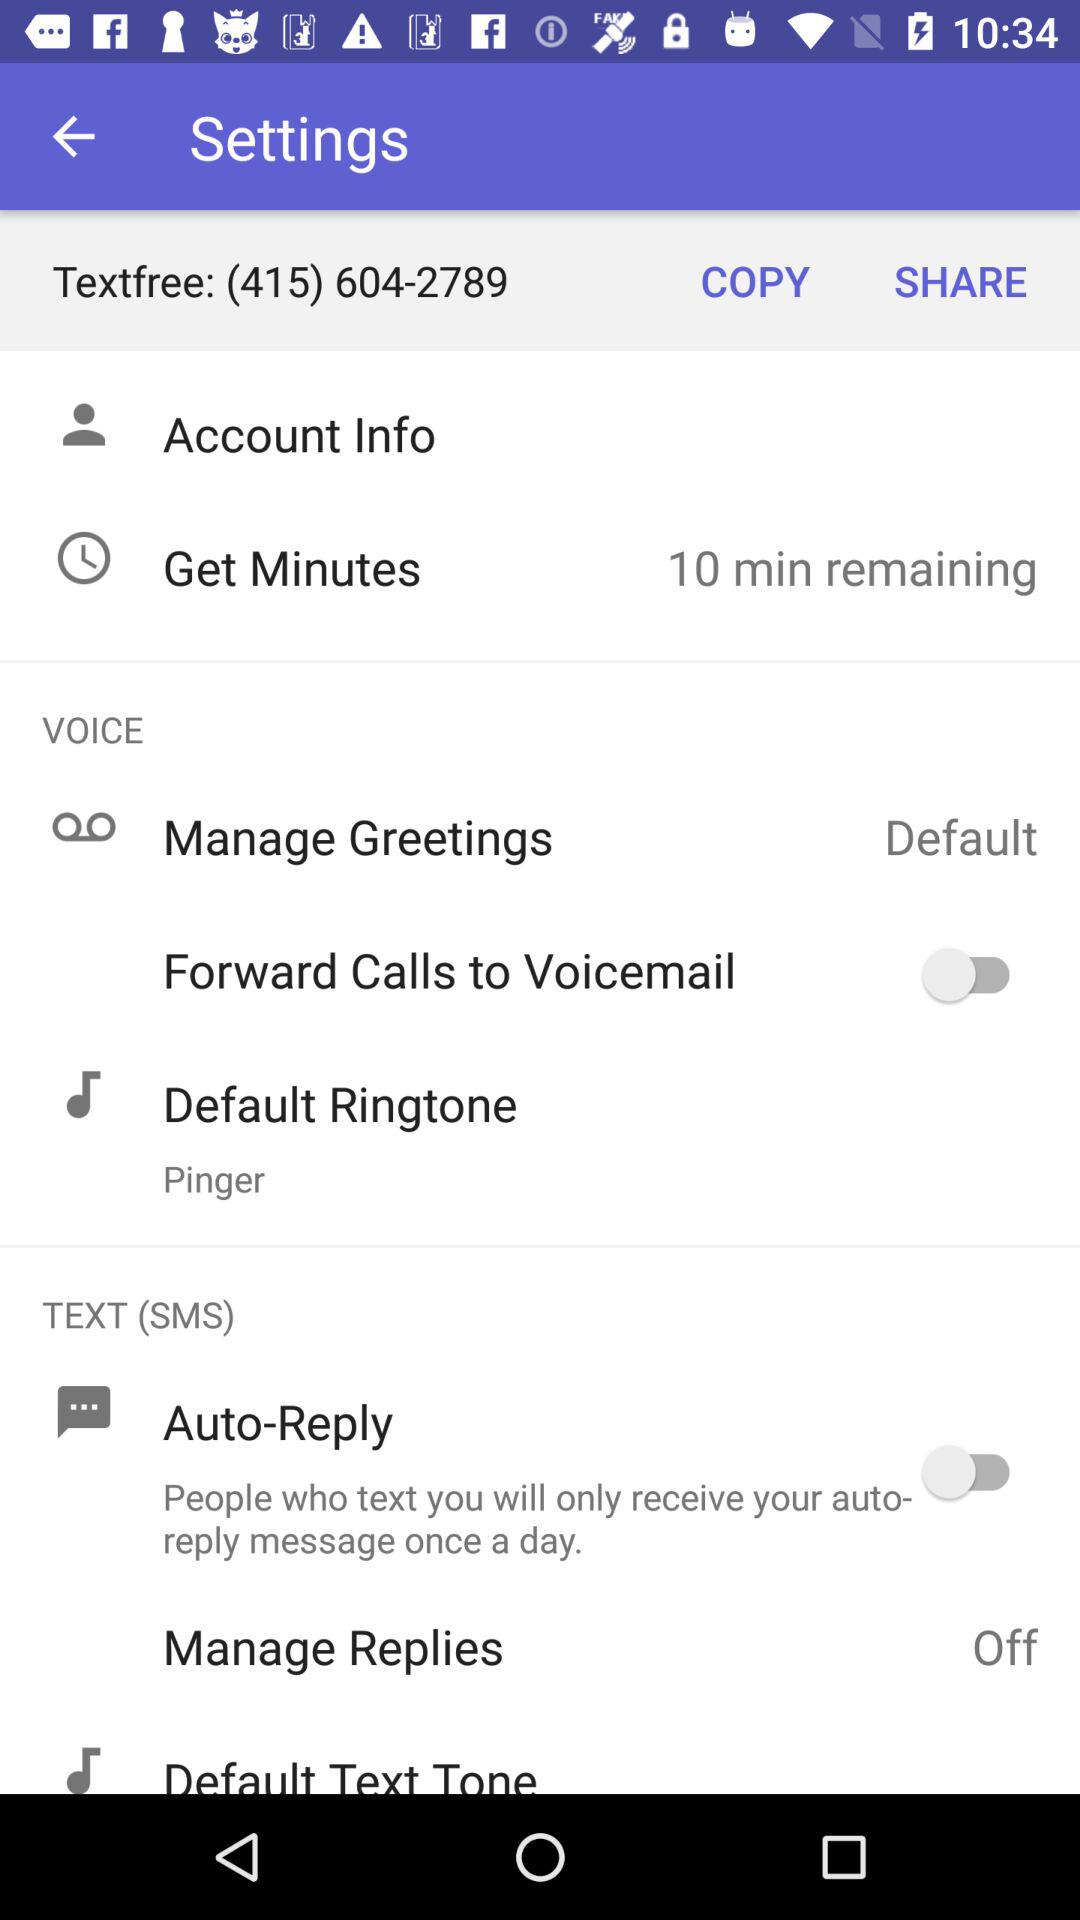What is the status of the "Forward Calls to Voicemail"? The status of the "Forward Calls to Voicemail" is "off". 